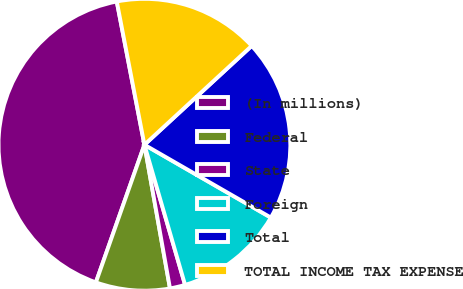Convert chart to OTSL. <chart><loc_0><loc_0><loc_500><loc_500><pie_chart><fcel>(In millions)<fcel>Federal<fcel>State<fcel>Foreign<fcel>Total<fcel>TOTAL INCOME TAX EXPENSE<nl><fcel>41.57%<fcel>8.2%<fcel>1.69%<fcel>12.19%<fcel>20.17%<fcel>16.18%<nl></chart> 